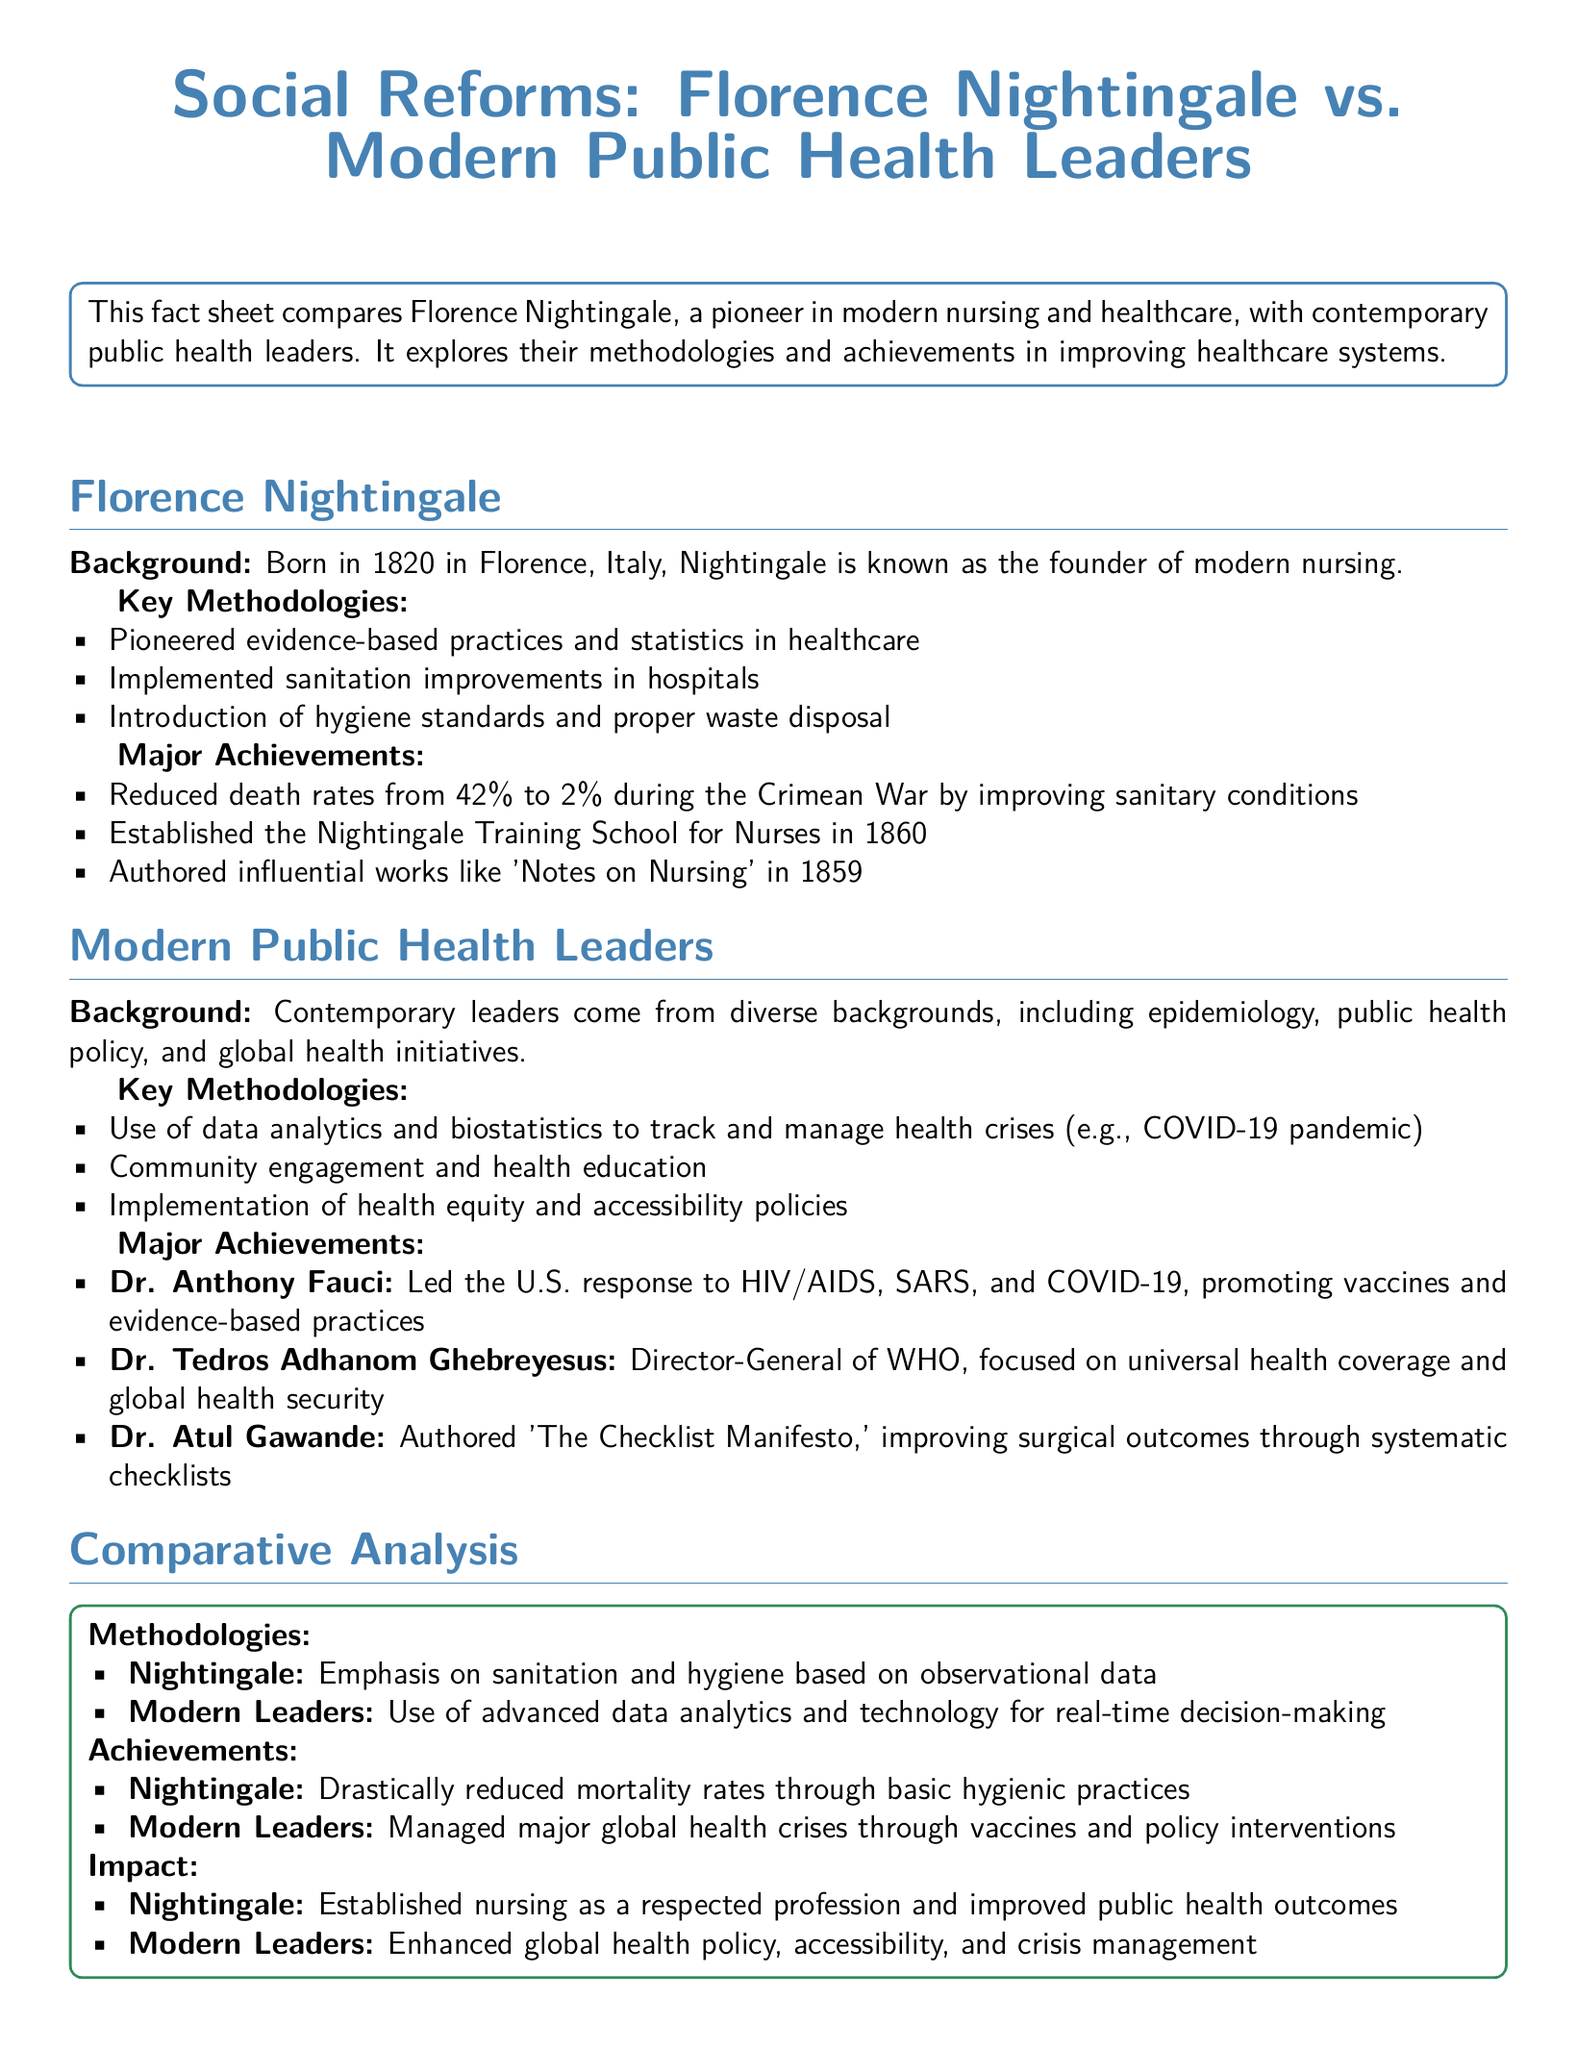What year was the Nightingale Training School for Nurses established? The document states that the Nightingale Training School for Nurses was established in 1860.
Answer: 1860 What percentage did Nightingale reduce the death rates to during the Crimean War? The document indicates that Nightingale reduced death rates from 42% to 2% during the Crimean War.
Answer: 2% Who is the Director-General of WHO mentioned in the document? The document mentions Dr. Tedros Adhanom Ghebreyesus as the Director-General of WHO.
Answer: Dr. Tedros Adhanom Ghebreyesus What was Nightingale's main focus in her methodologies? Nightingale's methodologies emphasized sanitation and hygiene based on observational data according to the document.
Answer: Sanitation and hygiene Which modern public health leader authored 'The Checklist Manifesto'? The document states that Dr. Atul Gawande authored 'The Checklist Manifesto'.
Answer: Dr. Atul Gawande What type of practices did Nightingale pioneer? The document describes Nightingale as a pioneer of evidence-based practices and statistics in healthcare.
Answer: Evidence-based practices How did modern leaders handle major global health crises according to the document? The document states that modern leaders managed major global health crises through vaccines and policy interventions.
Answer: Vaccines and policy interventions What is one major impact of Nightingale’s work mentioned in the document? The document notes that Nightingale established nursing as a respected profession and improved public health outcomes as a major impact of her work.
Answer: Established nursing as a respected profession 